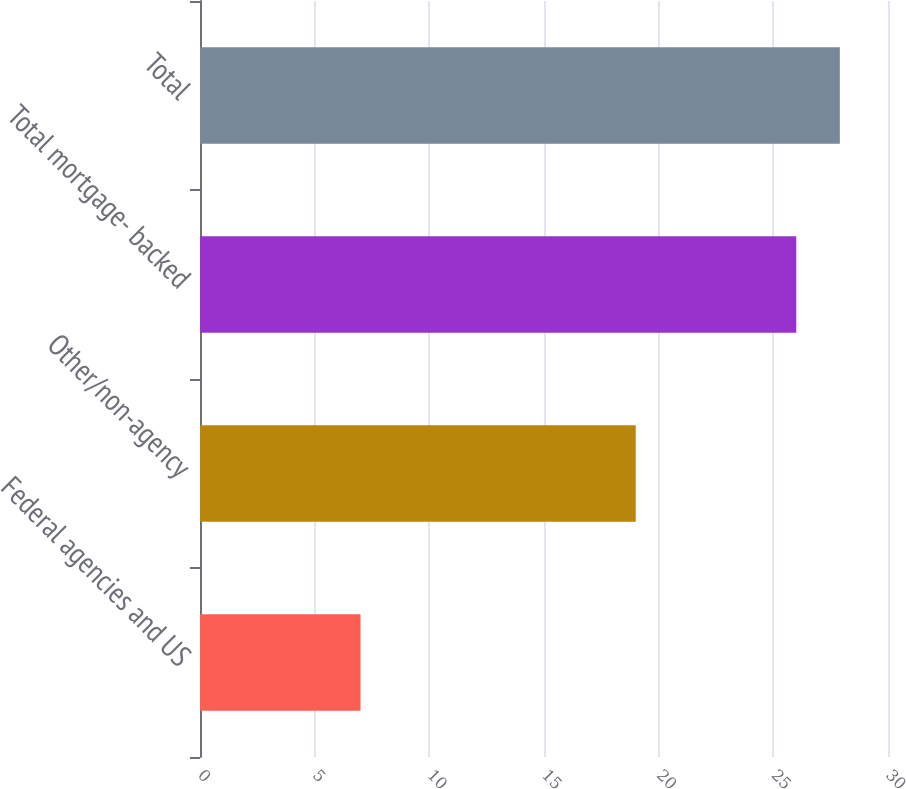Convert chart. <chart><loc_0><loc_0><loc_500><loc_500><bar_chart><fcel>Federal agencies and US<fcel>Other/non-agency<fcel>Total mortgage- backed<fcel>Total<nl><fcel>7<fcel>19<fcel>26<fcel>27.9<nl></chart> 